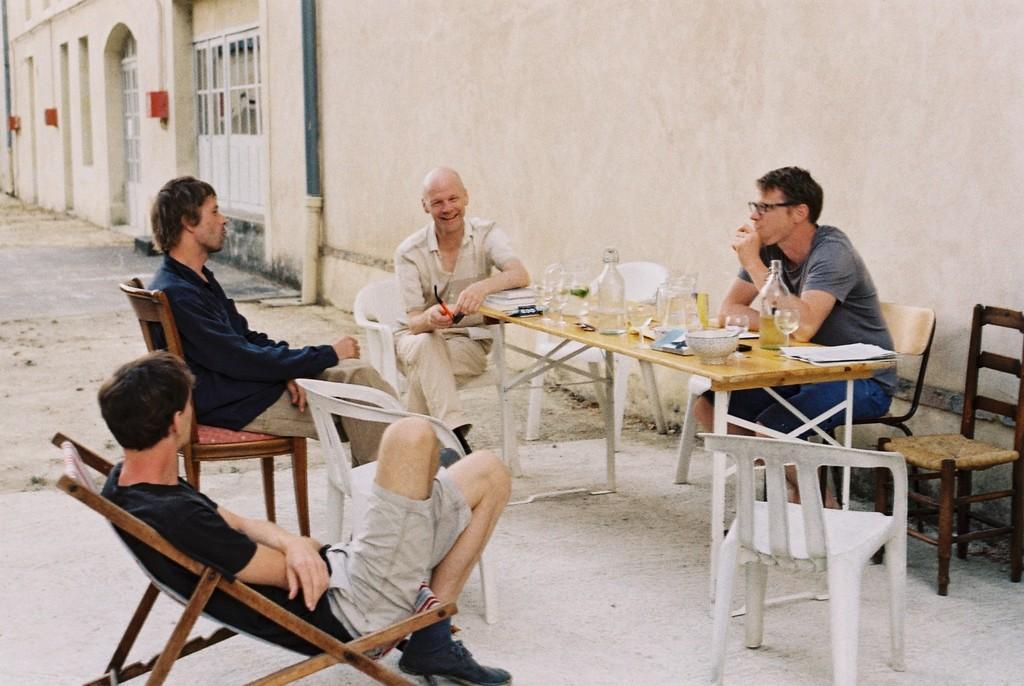In one or two sentences, can you explain what this image depicts? This is the picture of four people sitting around the table on which there are some things and beside them there are two other chairs. 